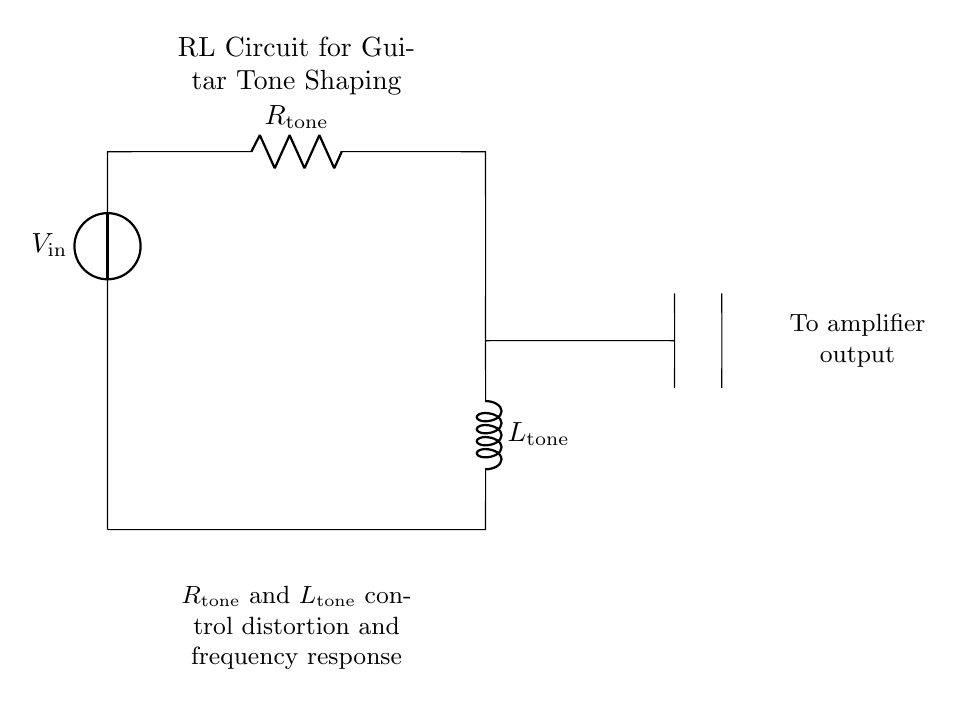What is the voltage source in this circuit? The voltage source is labeled as V_in, which supplies electrical energy to the circuit.
Answer: V_in What components are included in this RL circuit? The components are a resistor (R_tone) and an inductor (L_tone), which are essential for the tone shaping of an amplifier.
Answer: R_tone, L_tone In which direction does the current flow from the voltage source to the output? Current flows from the top to the bottom, first through the resistor and then through the inductor before reaching the output.
Answer: Top to bottom What is the purpose of the resistor in this circuit? The resistor R_tone controls the amount of current that flows through the circuit, influencing both distortion and frequency response.
Answer: Control current What happens to the frequency response when R_tone is increased? Increasing R_tone generally raises the circuit's resistance, which can result in a lower resonance frequency, thus affecting tone shaping in guitar amplifiers.
Answer: Lowers frequency What role does the inductor play in the RL circuit? The inductor L_tone reacts to changes in current and can store energy in a magnetic field, which contributes to the circuit's frequency response and distortion characteristics.
Answer: Stores energy How does the RL circuit impact distortion in guitar amplifiers? The combination of R_tone and L_tone allows the circuit to shape the waveform, thus controlling the amount of harmonic distortion and enhancing the tonal characteristics of the sound.
Answer: Shapes waveform 